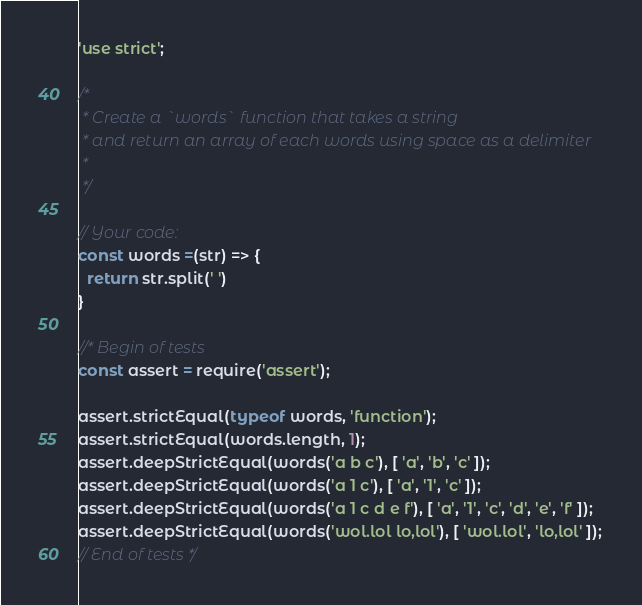Convert code to text. <code><loc_0><loc_0><loc_500><loc_500><_JavaScript_>'use strict';

/*
 * Create a `words` function that takes a string
 * and return an array of each words using space as a delimiter
 *
 */

// Your code:
const words =(str) => {
  return str.split(' ')
}

//* Begin of tests
const assert = require('assert');

assert.strictEqual(typeof words, 'function');
assert.strictEqual(words.length, 1);
assert.deepStrictEqual(words('a b c'), [ 'a', 'b', 'c' ]);
assert.deepStrictEqual(words('a 1 c'), [ 'a', '1', 'c' ]);
assert.deepStrictEqual(words('a 1 c d e f'), [ 'a', '1', 'c', 'd', 'e', 'f' ]);
assert.deepStrictEqual(words('wol.lol lo,lol'), [ 'wol.lol', 'lo,lol' ]);
// End of tests */
</code> 